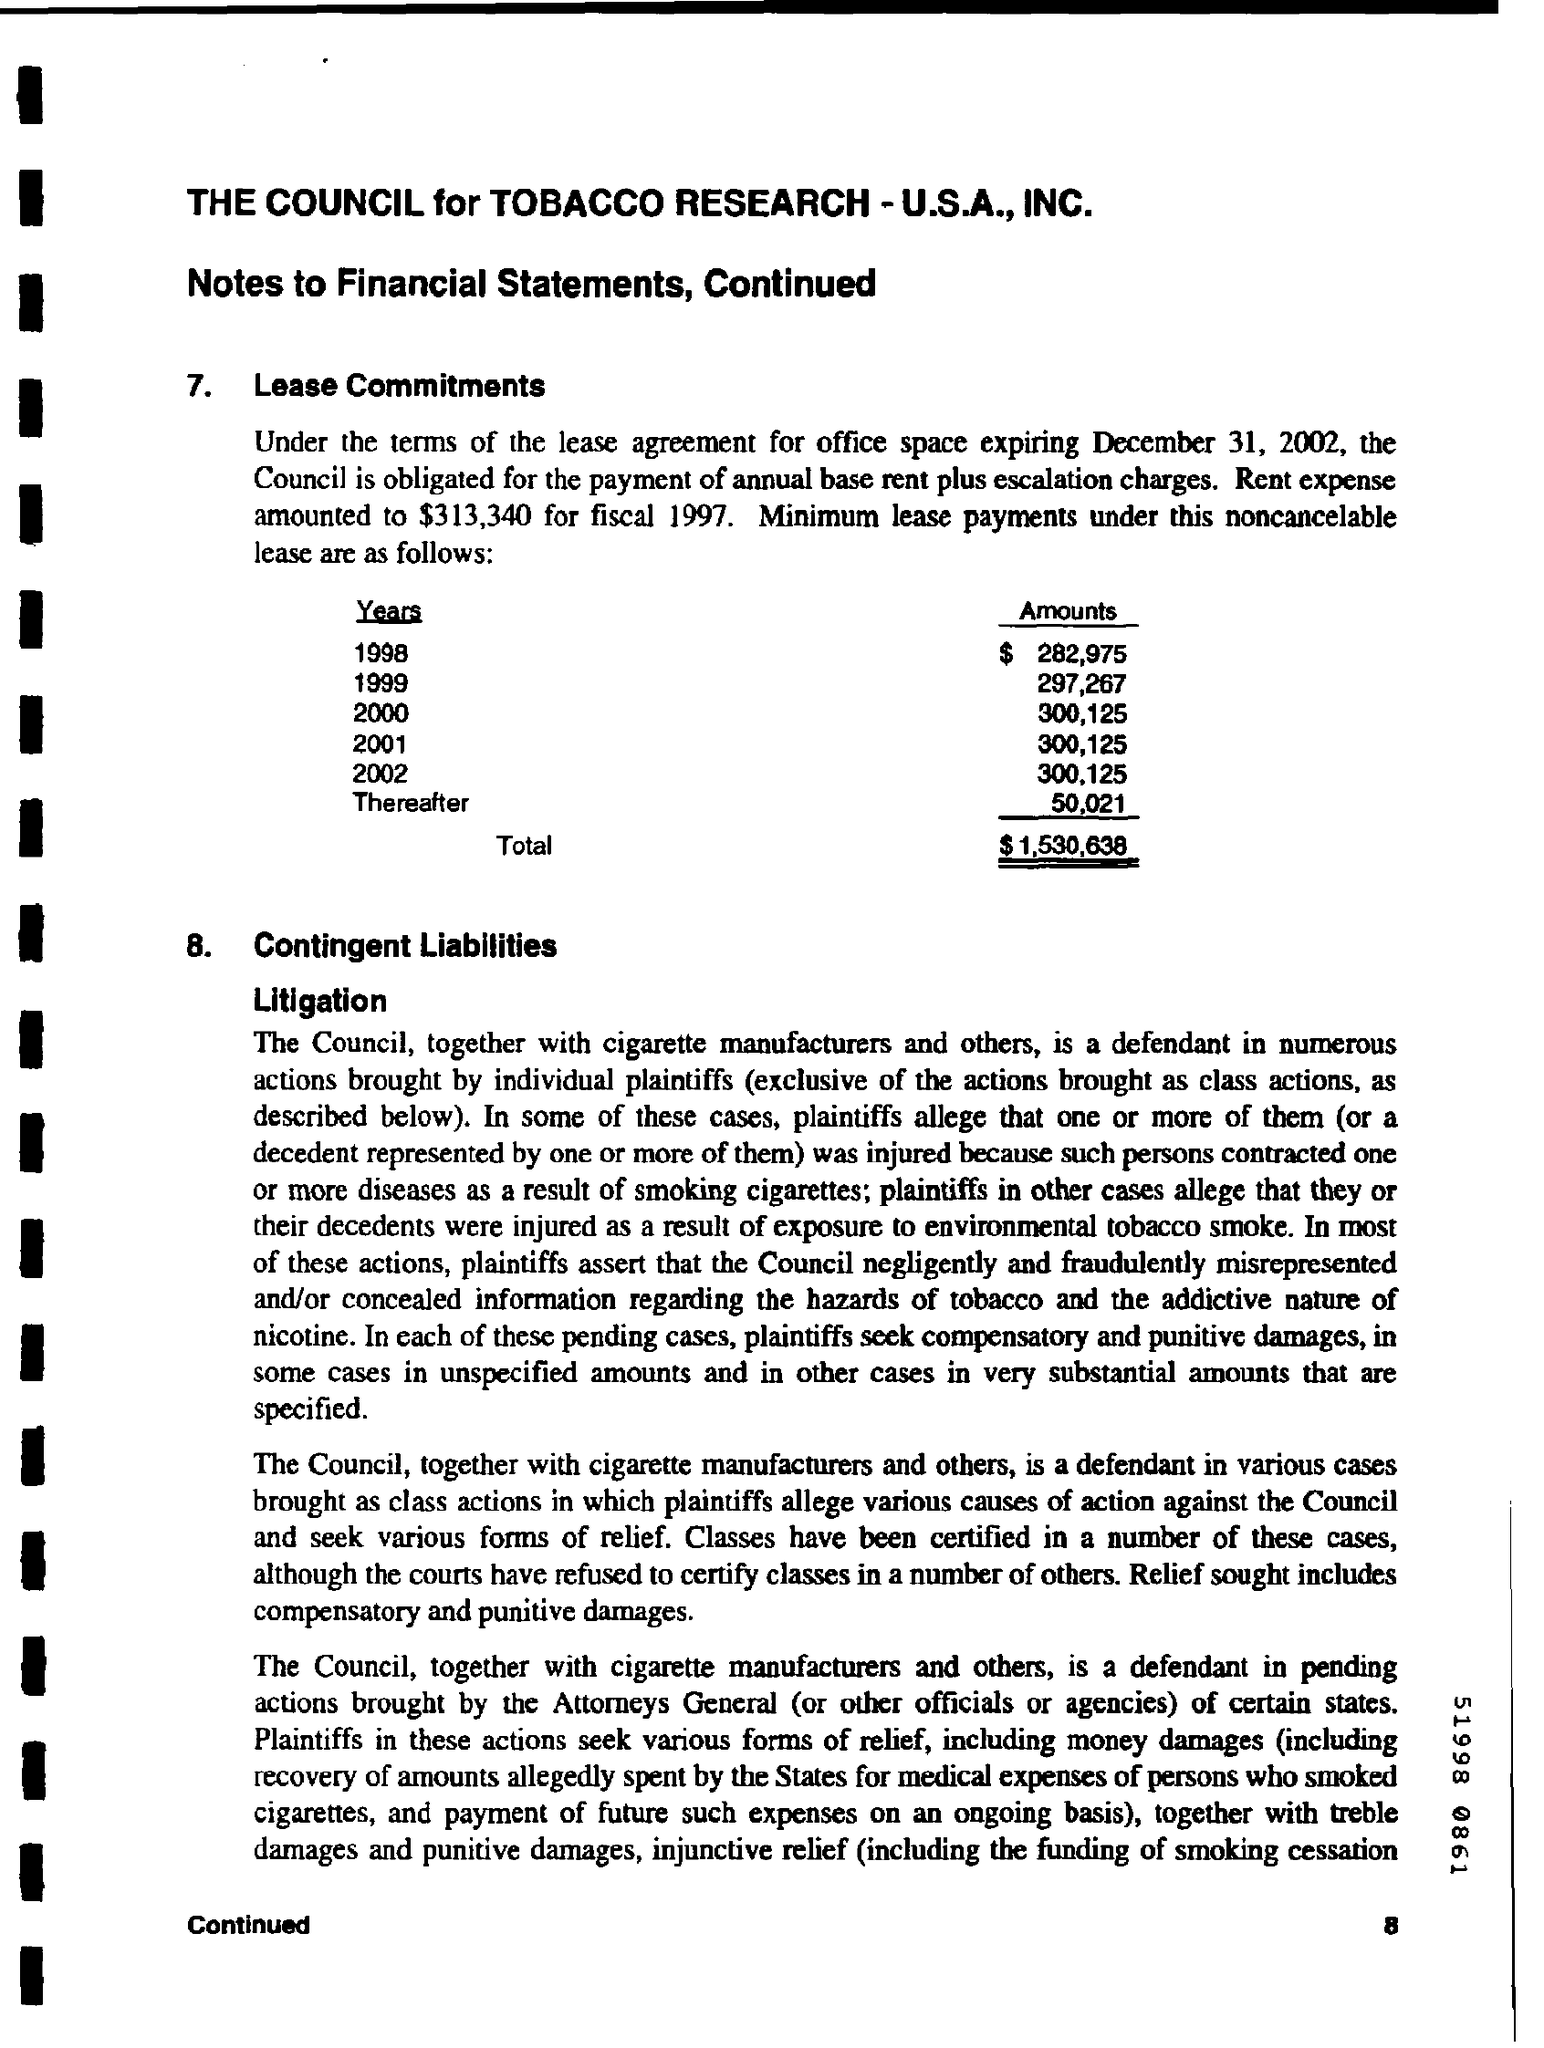What is the amounts given for the year 1998 ?
Your response must be concise. $ 282,975. What is the amounts given for the year 1999 ?
Provide a short and direct response. $297,267. What is the amounts given for the year 2000 ?
Give a very brief answer. 300,125. What is the amounts given for the year 2001 ?
Keep it short and to the point. 300,125. What is the amounts given for the year 2002 ?
Your answer should be compact. $ 300,125. What is the total amount mentioned in the given form ?
Your answer should be very brief. $ 1,530,638. 